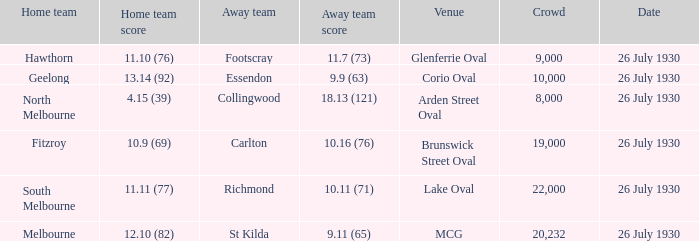Where did Geelong play a home game? Corio Oval. 